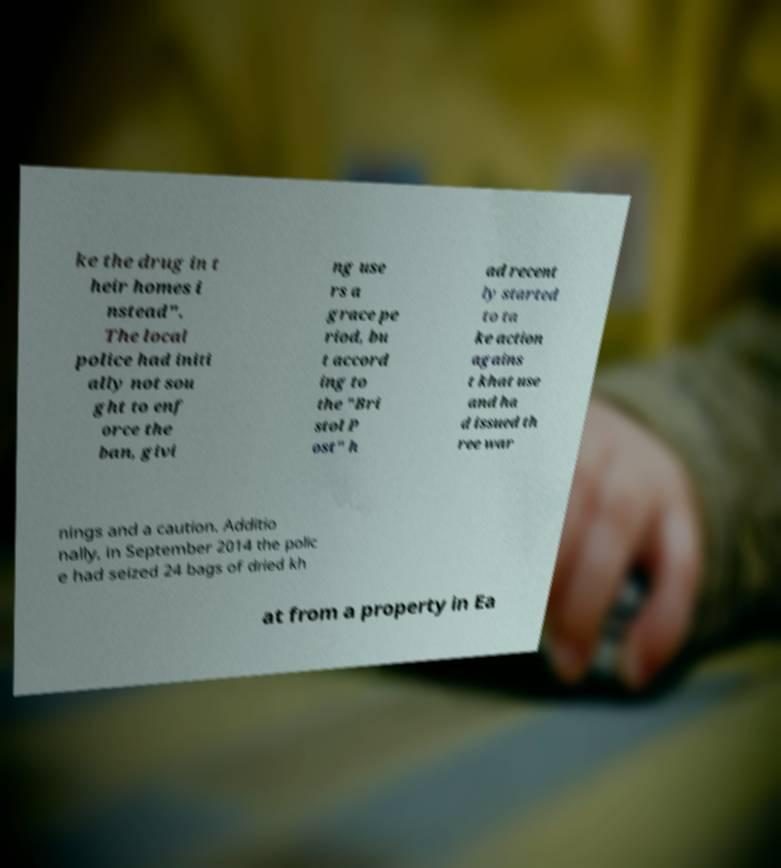Can you read and provide the text displayed in the image?This photo seems to have some interesting text. Can you extract and type it out for me? ke the drug in t heir homes i nstead". The local police had initi ally not sou ght to enf orce the ban, givi ng use rs a grace pe riod, bu t accord ing to the "Bri stol P ost" h ad recent ly started to ta ke action agains t khat use and ha d issued th ree war nings and a caution. Additio nally, in September 2014 the polic e had seized 24 bags of dried kh at from a property in Ea 